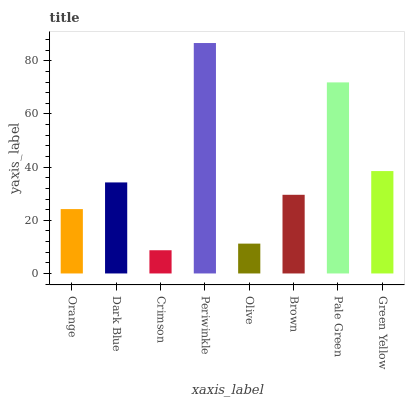Is Dark Blue the minimum?
Answer yes or no. No. Is Dark Blue the maximum?
Answer yes or no. No. Is Dark Blue greater than Orange?
Answer yes or no. Yes. Is Orange less than Dark Blue?
Answer yes or no. Yes. Is Orange greater than Dark Blue?
Answer yes or no. No. Is Dark Blue less than Orange?
Answer yes or no. No. Is Dark Blue the high median?
Answer yes or no. Yes. Is Brown the low median?
Answer yes or no. Yes. Is Crimson the high median?
Answer yes or no. No. Is Pale Green the low median?
Answer yes or no. No. 